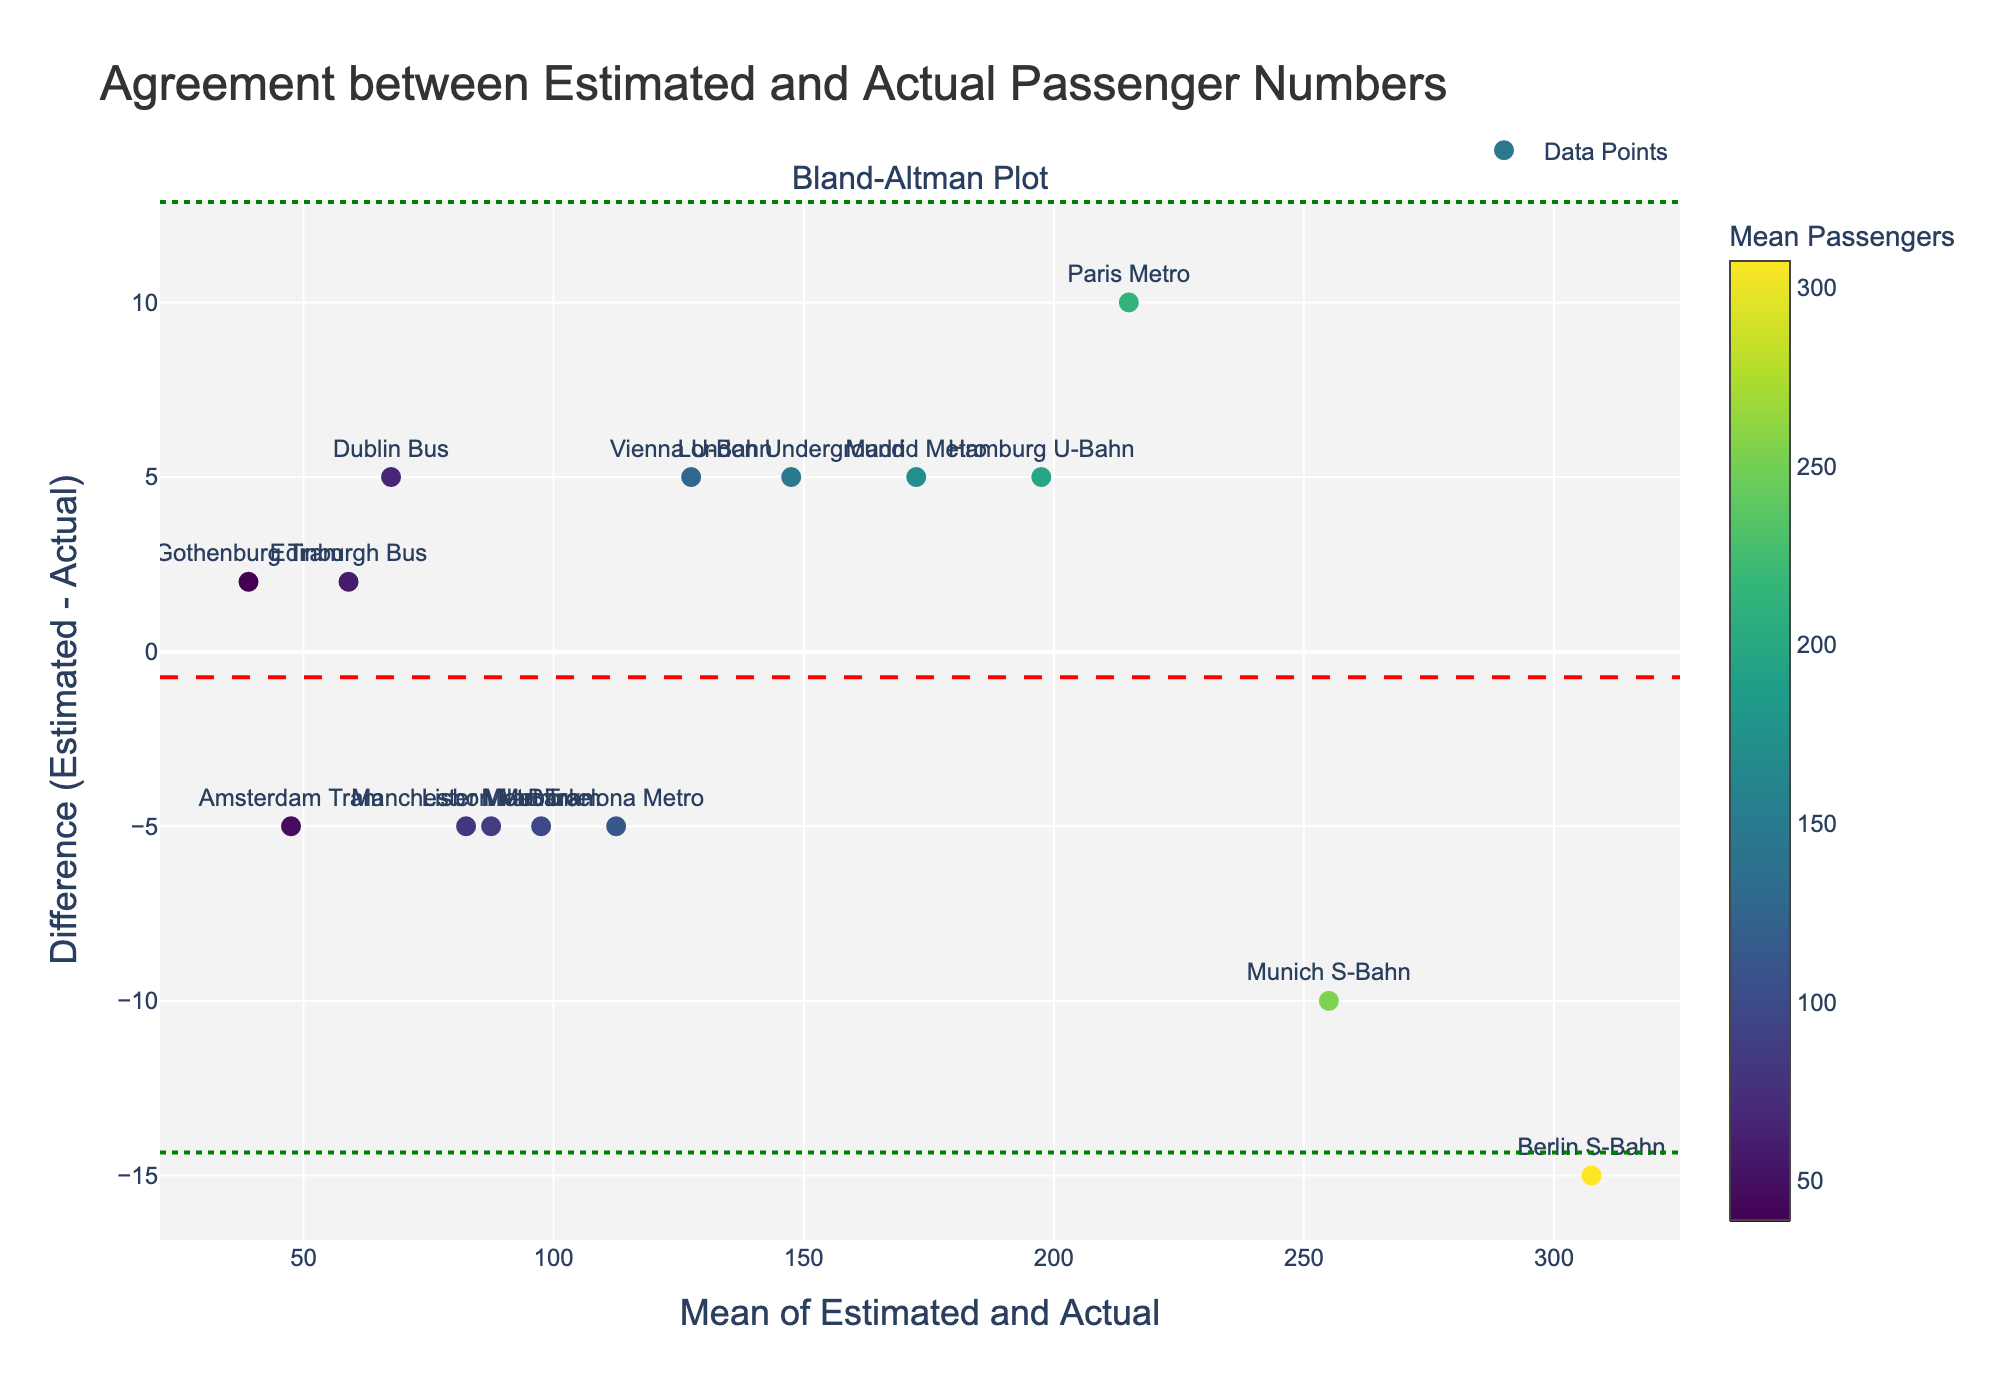What is the title of the plot? The title is displayed at the top of the figure. It is written in a larger font size for emphasis.
Answer: Agreement between Estimated and Actual Passenger Numbers What is the mean difference between the estimated and actual passenger numbers? The mean difference is indicated by the red dashed horizontal line on the plot. The value of this line represents the mean difference.
Answer: -1.33 What does the green dotted line above the mean difference represent? This line represents the upper limit of agreement (Upper LoA). The Bland-Altman plot shows this to assess the expected range of differences.
Answer: Upper LoA How many data points are there in the plot? Each marker on the plot represents one data point. Counting these markers will give the total number of data points.
Answer: 15 What are the x-axis and y-axis titles? The x-axis title is located along the horizontal axis, and the y-axis title is along the vertical axis.
Answer: Mean of Estimated and Actual (x-axis) and Difference (Estimated - Actual) (y-axis) Which mode has the largest difference in passenger numbers? Look for the marker that is farthest from the horizontal zero line on the y-axis. Hovering over each marker can show the mode and its values.
Answer: Berlin S-Bahn Which mode shows the closest agreement between estimated and actual passenger numbers? The closest agreement is indicated by the marker closest to the horizontal zero line, as its difference is the smallest.
Answer: Edinburgh Bus Is there any mode of transport where the actual number of passengers is consistently underestimated? If the difference (Estimated - Actual) is mostly negative, it indicates underestimation. Look for markers below the zero line.
Answer: Yes Which data point shows the highest mean number of passengers? The highest value on the x-axis (Mean of Estimated and Actual) corresponds to the highest mean passenger number.
Answer: Berlin S-Bahn Are there more data points with positive or negative differences? Count the number of markers above and below the zero line. The markers above represent positive differences, while those below are negative differences.
Answer: More negative differences 